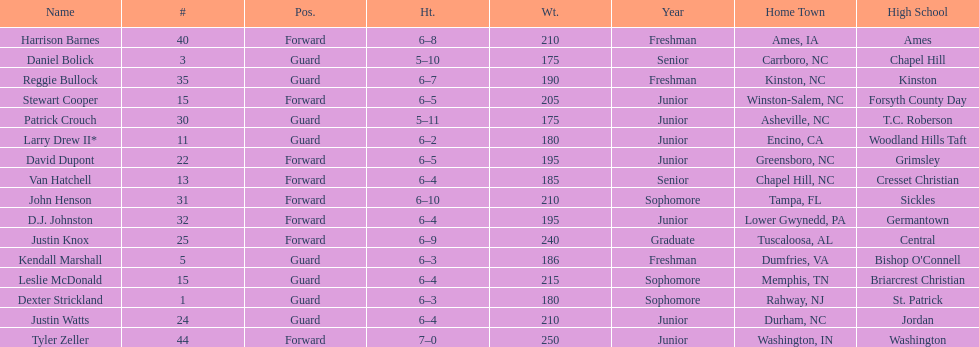Tallest player on the team Tyler Zeller. 